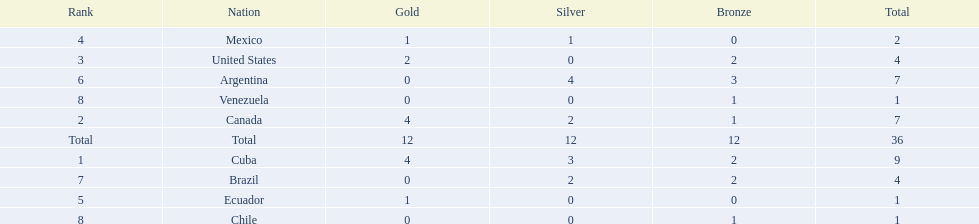Who is ranked #1? Cuba. 